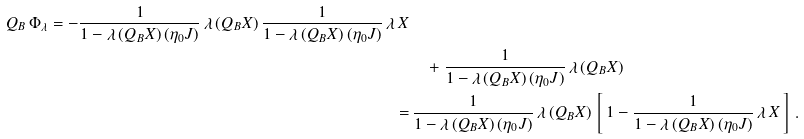<formula> <loc_0><loc_0><loc_500><loc_500>Q _ { B } \, \Phi _ { \lambda } = - \frac { 1 } { 1 - \lambda \, ( Q _ { B } X ) \, ( \eta _ { 0 } J ) } \, \lambda \, ( Q _ { B } X ) \, \frac { 1 } { 1 - \lambda \, ( Q _ { B } X ) \, ( \eta _ { 0 } J ) } \, \lambda \, X \\ & \quad + \frac { 1 } { 1 - \lambda \, ( Q _ { B } X ) \, ( \eta _ { 0 } J ) } \, \lambda \, ( Q _ { B } X ) \\ = & \, \frac { 1 } { 1 - \lambda \, ( Q _ { B } X ) \, ( \eta _ { 0 } J ) } \, \lambda \, ( Q _ { B } X ) \, \left [ \, 1 - \frac { 1 } { 1 - \lambda \, ( Q _ { B } X ) \, ( \eta _ { 0 } J ) } \, \lambda \, X \, \right ] \, .</formula> 